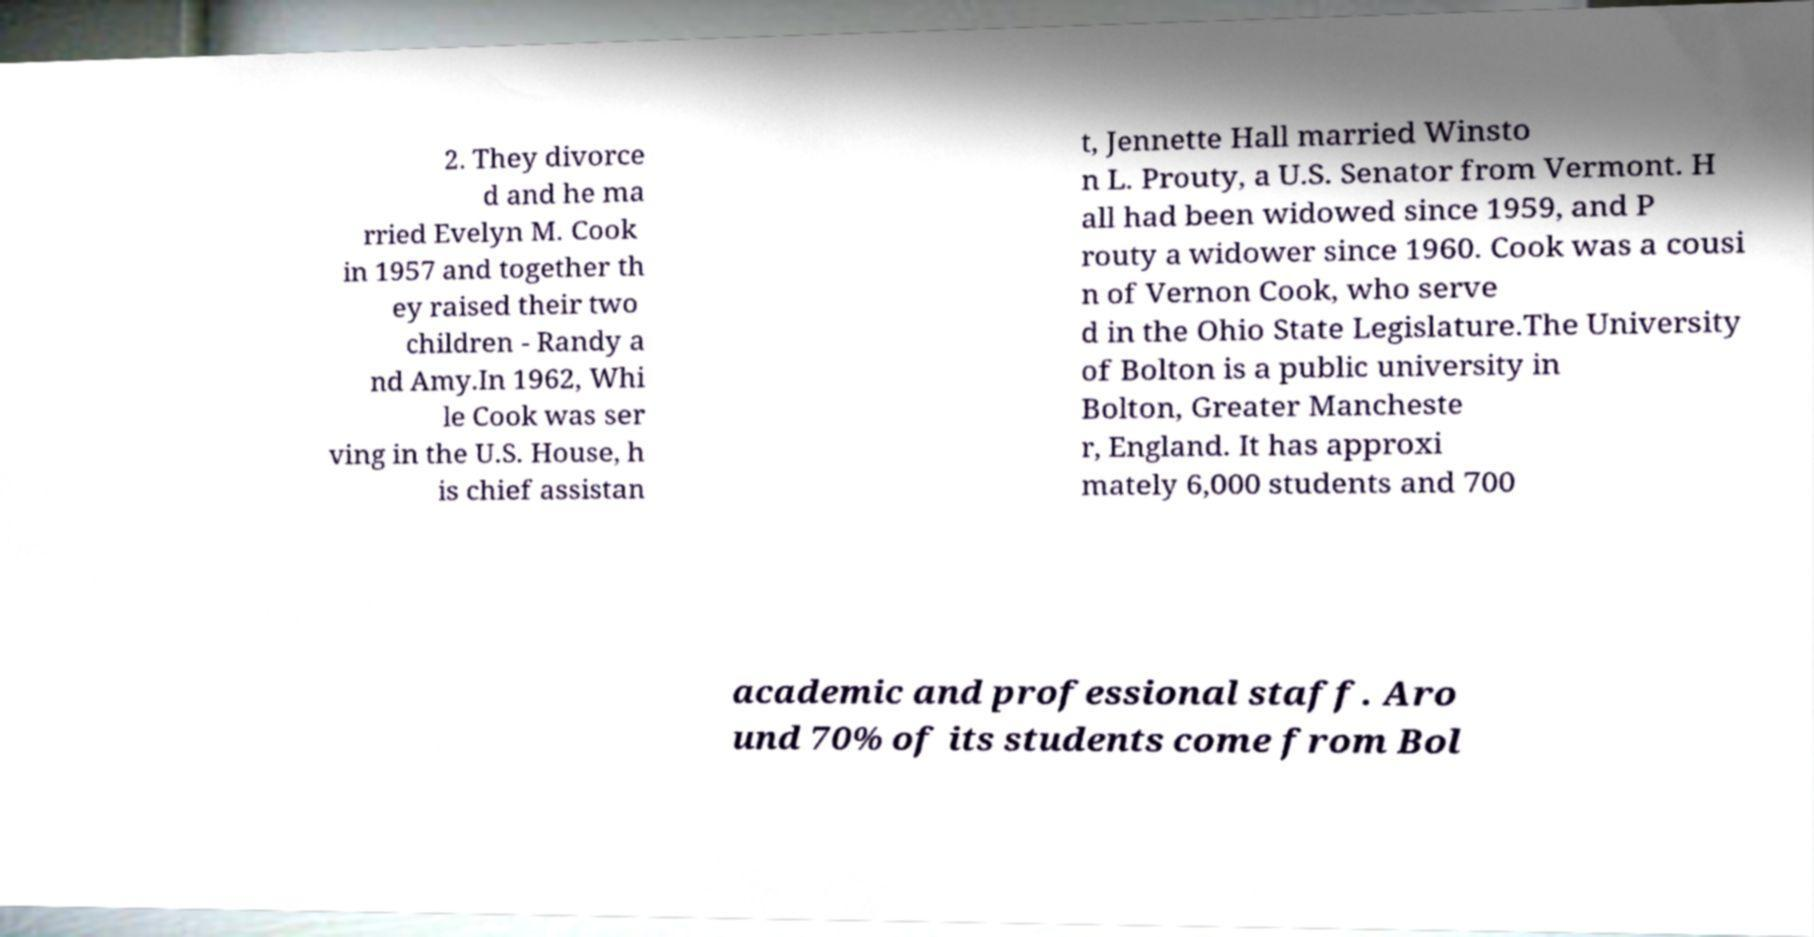Can you read and provide the text displayed in the image?This photo seems to have some interesting text. Can you extract and type it out for me? 2. They divorce d and he ma rried Evelyn M. Cook in 1957 and together th ey raised their two children - Randy a nd Amy.In 1962, Whi le Cook was ser ving in the U.S. House, h is chief assistan t, Jennette Hall married Winsto n L. Prouty, a U.S. Senator from Vermont. H all had been widowed since 1959, and P routy a widower since 1960. Cook was a cousi n of Vernon Cook, who serve d in the Ohio State Legislature.The University of Bolton is a public university in Bolton, Greater Mancheste r, England. It has approxi mately 6,000 students and 700 academic and professional staff. Aro und 70% of its students come from Bol 